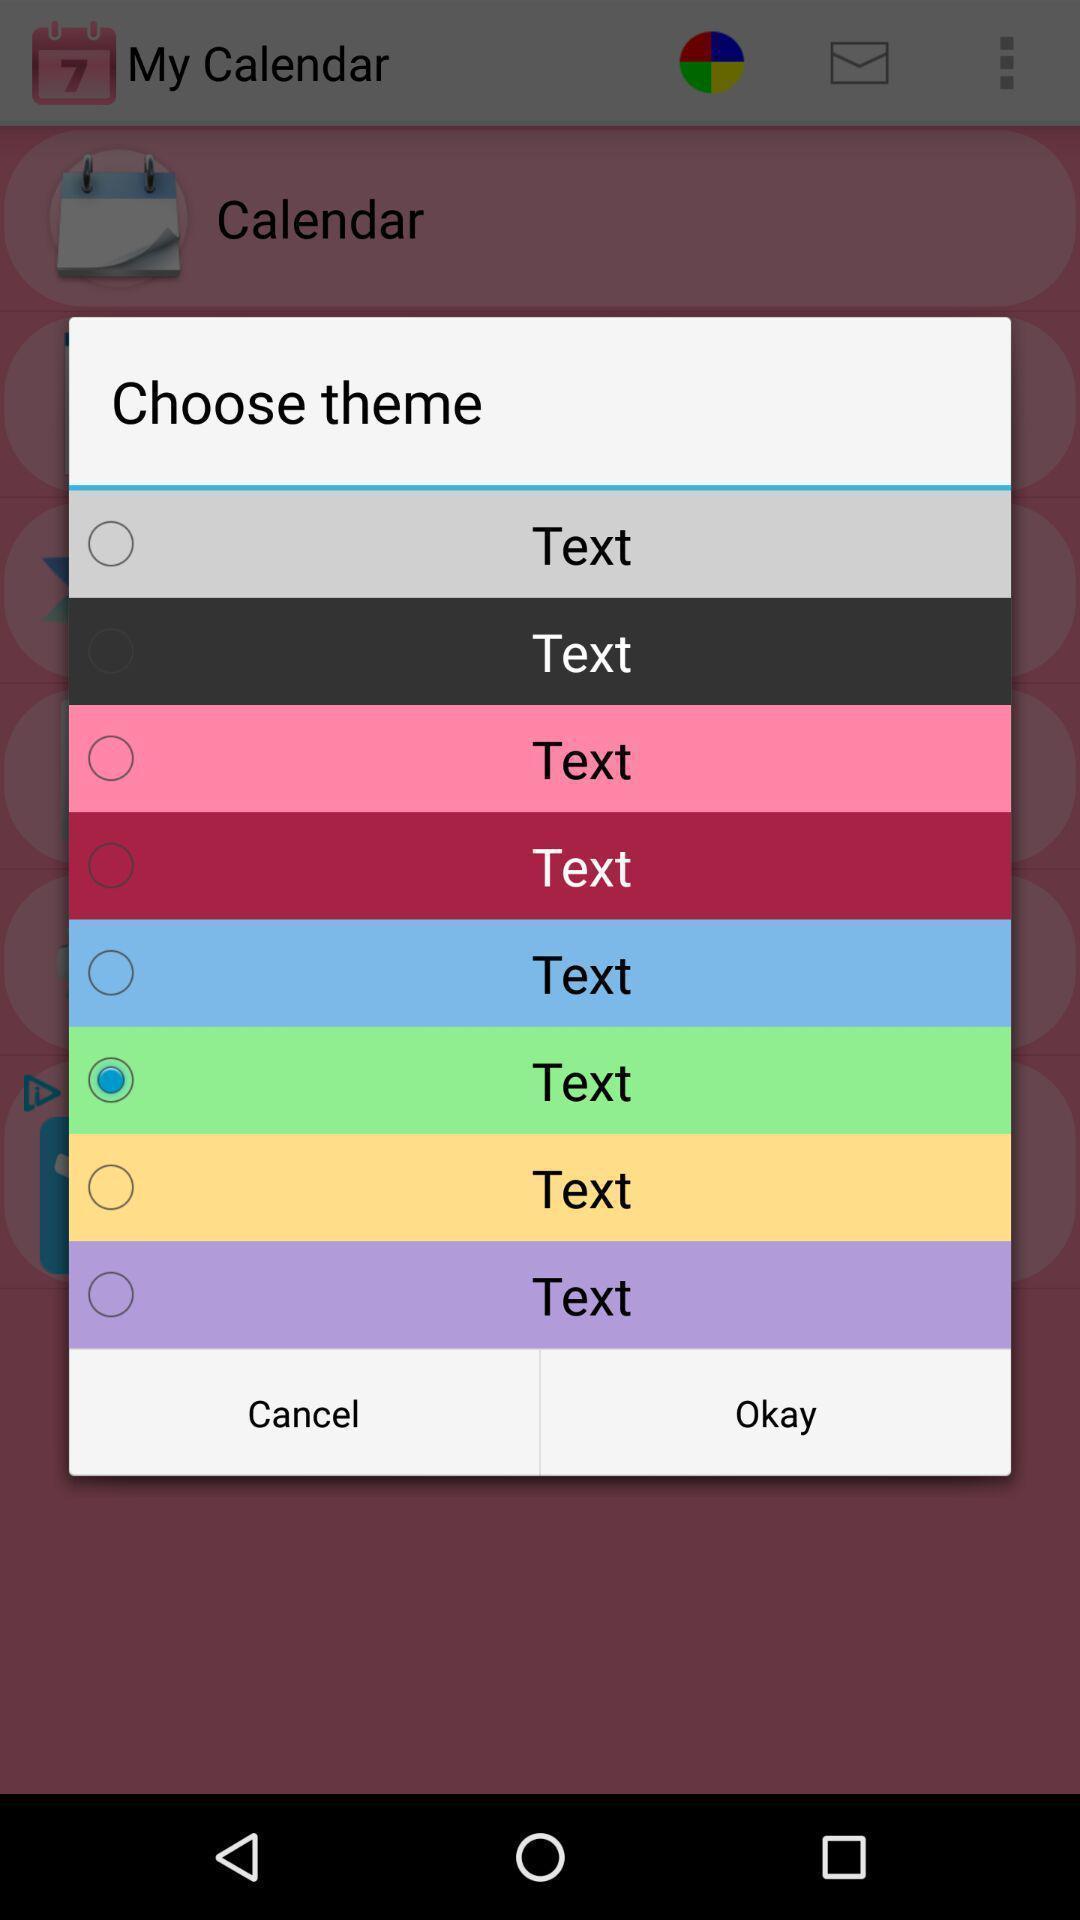Describe the visual elements of this screenshot. Popup of different colors to select in the application. 